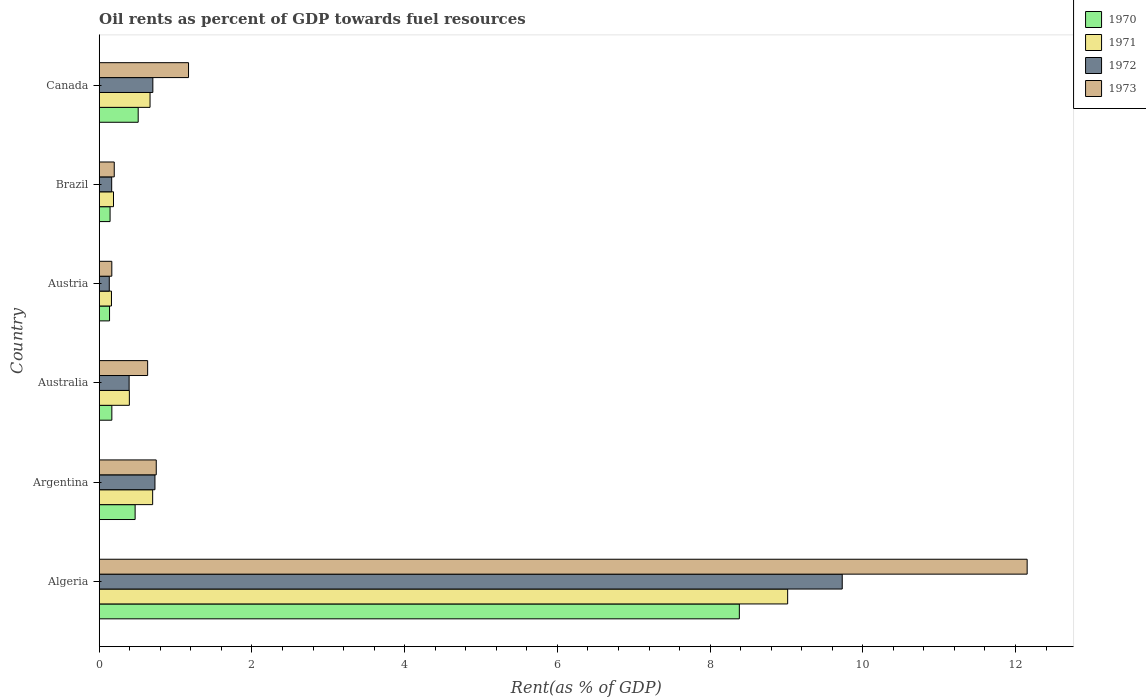How many different coloured bars are there?
Offer a terse response. 4. Are the number of bars per tick equal to the number of legend labels?
Offer a very short reply. Yes. Are the number of bars on each tick of the Y-axis equal?
Offer a very short reply. Yes. How many bars are there on the 4th tick from the bottom?
Offer a very short reply. 4. What is the label of the 6th group of bars from the top?
Keep it short and to the point. Algeria. In how many cases, is the number of bars for a given country not equal to the number of legend labels?
Provide a short and direct response. 0. What is the oil rent in 1970 in Canada?
Give a very brief answer. 0.51. Across all countries, what is the maximum oil rent in 1970?
Your answer should be very brief. 8.38. Across all countries, what is the minimum oil rent in 1970?
Provide a succinct answer. 0.14. In which country was the oil rent in 1970 maximum?
Your answer should be compact. Algeria. In which country was the oil rent in 1970 minimum?
Provide a short and direct response. Austria. What is the total oil rent in 1973 in the graph?
Offer a very short reply. 15.06. What is the difference between the oil rent in 1971 in Algeria and that in Brazil?
Your answer should be compact. 8.83. What is the difference between the oil rent in 1973 in Argentina and the oil rent in 1970 in Algeria?
Make the answer very short. -7.64. What is the average oil rent in 1972 per country?
Your answer should be compact. 1.97. What is the difference between the oil rent in 1970 and oil rent in 1972 in Canada?
Your answer should be very brief. -0.19. In how many countries, is the oil rent in 1971 greater than 3.6 %?
Keep it short and to the point. 1. What is the ratio of the oil rent in 1970 in Brazil to that in Canada?
Your response must be concise. 0.28. Is the oil rent in 1970 in Australia less than that in Brazil?
Keep it short and to the point. No. What is the difference between the highest and the second highest oil rent in 1973?
Keep it short and to the point. 10.98. What is the difference between the highest and the lowest oil rent in 1973?
Ensure brevity in your answer.  11.99. Is the sum of the oil rent in 1972 in Algeria and Canada greater than the maximum oil rent in 1973 across all countries?
Provide a succinct answer. No. Is it the case that in every country, the sum of the oil rent in 1971 and oil rent in 1972 is greater than the sum of oil rent in 1970 and oil rent in 1973?
Offer a very short reply. No. What does the 2nd bar from the bottom in Brazil represents?
Offer a terse response. 1971. Is it the case that in every country, the sum of the oil rent in 1972 and oil rent in 1971 is greater than the oil rent in 1973?
Offer a very short reply. Yes. How many bars are there?
Your answer should be very brief. 24. Are all the bars in the graph horizontal?
Keep it short and to the point. Yes. What is the difference between two consecutive major ticks on the X-axis?
Your response must be concise. 2. Are the values on the major ticks of X-axis written in scientific E-notation?
Give a very brief answer. No. Does the graph contain any zero values?
Keep it short and to the point. No. How many legend labels are there?
Ensure brevity in your answer.  4. How are the legend labels stacked?
Ensure brevity in your answer.  Vertical. What is the title of the graph?
Your response must be concise. Oil rents as percent of GDP towards fuel resources. What is the label or title of the X-axis?
Provide a short and direct response. Rent(as % of GDP). What is the Rent(as % of GDP) of 1970 in Algeria?
Ensure brevity in your answer.  8.38. What is the Rent(as % of GDP) of 1971 in Algeria?
Offer a terse response. 9.02. What is the Rent(as % of GDP) in 1972 in Algeria?
Your answer should be compact. 9.73. What is the Rent(as % of GDP) in 1973 in Algeria?
Your answer should be very brief. 12.15. What is the Rent(as % of GDP) of 1970 in Argentina?
Provide a short and direct response. 0.47. What is the Rent(as % of GDP) of 1971 in Argentina?
Your response must be concise. 0.7. What is the Rent(as % of GDP) in 1972 in Argentina?
Keep it short and to the point. 0.73. What is the Rent(as % of GDP) of 1973 in Argentina?
Your response must be concise. 0.75. What is the Rent(as % of GDP) of 1970 in Australia?
Your answer should be compact. 0.17. What is the Rent(as % of GDP) in 1971 in Australia?
Your answer should be very brief. 0.39. What is the Rent(as % of GDP) in 1972 in Australia?
Offer a terse response. 0.39. What is the Rent(as % of GDP) of 1973 in Australia?
Offer a very short reply. 0.63. What is the Rent(as % of GDP) of 1970 in Austria?
Ensure brevity in your answer.  0.14. What is the Rent(as % of GDP) in 1971 in Austria?
Ensure brevity in your answer.  0.16. What is the Rent(as % of GDP) in 1972 in Austria?
Your answer should be very brief. 0.13. What is the Rent(as % of GDP) of 1973 in Austria?
Your response must be concise. 0.16. What is the Rent(as % of GDP) of 1970 in Brazil?
Make the answer very short. 0.14. What is the Rent(as % of GDP) of 1971 in Brazil?
Your answer should be very brief. 0.19. What is the Rent(as % of GDP) of 1972 in Brazil?
Your answer should be very brief. 0.16. What is the Rent(as % of GDP) of 1973 in Brazil?
Make the answer very short. 0.2. What is the Rent(as % of GDP) of 1970 in Canada?
Provide a succinct answer. 0.51. What is the Rent(as % of GDP) of 1971 in Canada?
Make the answer very short. 0.67. What is the Rent(as % of GDP) of 1972 in Canada?
Ensure brevity in your answer.  0.7. What is the Rent(as % of GDP) in 1973 in Canada?
Keep it short and to the point. 1.17. Across all countries, what is the maximum Rent(as % of GDP) in 1970?
Offer a very short reply. 8.38. Across all countries, what is the maximum Rent(as % of GDP) of 1971?
Make the answer very short. 9.02. Across all countries, what is the maximum Rent(as % of GDP) of 1972?
Offer a very short reply. 9.73. Across all countries, what is the maximum Rent(as % of GDP) of 1973?
Your answer should be compact. 12.15. Across all countries, what is the minimum Rent(as % of GDP) of 1970?
Make the answer very short. 0.14. Across all countries, what is the minimum Rent(as % of GDP) in 1971?
Your answer should be compact. 0.16. Across all countries, what is the minimum Rent(as % of GDP) in 1972?
Offer a very short reply. 0.13. Across all countries, what is the minimum Rent(as % of GDP) in 1973?
Offer a terse response. 0.16. What is the total Rent(as % of GDP) of 1970 in the graph?
Your answer should be compact. 9.81. What is the total Rent(as % of GDP) of 1971 in the graph?
Offer a very short reply. 11.12. What is the total Rent(as % of GDP) of 1972 in the graph?
Provide a succinct answer. 11.85. What is the total Rent(as % of GDP) of 1973 in the graph?
Offer a very short reply. 15.06. What is the difference between the Rent(as % of GDP) in 1970 in Algeria and that in Argentina?
Give a very brief answer. 7.91. What is the difference between the Rent(as % of GDP) of 1971 in Algeria and that in Argentina?
Ensure brevity in your answer.  8.32. What is the difference between the Rent(as % of GDP) of 1972 in Algeria and that in Argentina?
Keep it short and to the point. 9. What is the difference between the Rent(as % of GDP) in 1973 in Algeria and that in Argentina?
Make the answer very short. 11.41. What is the difference between the Rent(as % of GDP) of 1970 in Algeria and that in Australia?
Provide a short and direct response. 8.22. What is the difference between the Rent(as % of GDP) of 1971 in Algeria and that in Australia?
Make the answer very short. 8.62. What is the difference between the Rent(as % of GDP) in 1972 in Algeria and that in Australia?
Offer a terse response. 9.34. What is the difference between the Rent(as % of GDP) in 1973 in Algeria and that in Australia?
Your answer should be very brief. 11.52. What is the difference between the Rent(as % of GDP) in 1970 in Algeria and that in Austria?
Ensure brevity in your answer.  8.25. What is the difference between the Rent(as % of GDP) of 1971 in Algeria and that in Austria?
Keep it short and to the point. 8.86. What is the difference between the Rent(as % of GDP) of 1972 in Algeria and that in Austria?
Make the answer very short. 9.6. What is the difference between the Rent(as % of GDP) in 1973 in Algeria and that in Austria?
Your answer should be very brief. 11.99. What is the difference between the Rent(as % of GDP) of 1970 in Algeria and that in Brazil?
Offer a very short reply. 8.24. What is the difference between the Rent(as % of GDP) of 1971 in Algeria and that in Brazil?
Offer a very short reply. 8.83. What is the difference between the Rent(as % of GDP) of 1972 in Algeria and that in Brazil?
Make the answer very short. 9.57. What is the difference between the Rent(as % of GDP) of 1973 in Algeria and that in Brazil?
Your answer should be compact. 11.96. What is the difference between the Rent(as % of GDP) of 1970 in Algeria and that in Canada?
Your answer should be compact. 7.87. What is the difference between the Rent(as % of GDP) in 1971 in Algeria and that in Canada?
Your answer should be compact. 8.35. What is the difference between the Rent(as % of GDP) in 1972 in Algeria and that in Canada?
Provide a short and direct response. 9.03. What is the difference between the Rent(as % of GDP) in 1973 in Algeria and that in Canada?
Ensure brevity in your answer.  10.98. What is the difference between the Rent(as % of GDP) in 1970 in Argentina and that in Australia?
Keep it short and to the point. 0.3. What is the difference between the Rent(as % of GDP) of 1971 in Argentina and that in Australia?
Give a very brief answer. 0.31. What is the difference between the Rent(as % of GDP) in 1972 in Argentina and that in Australia?
Your answer should be very brief. 0.34. What is the difference between the Rent(as % of GDP) of 1973 in Argentina and that in Australia?
Give a very brief answer. 0.11. What is the difference between the Rent(as % of GDP) of 1970 in Argentina and that in Austria?
Offer a terse response. 0.33. What is the difference between the Rent(as % of GDP) in 1971 in Argentina and that in Austria?
Make the answer very short. 0.54. What is the difference between the Rent(as % of GDP) in 1972 in Argentina and that in Austria?
Make the answer very short. 0.6. What is the difference between the Rent(as % of GDP) in 1973 in Argentina and that in Austria?
Provide a succinct answer. 0.58. What is the difference between the Rent(as % of GDP) of 1970 in Argentina and that in Brazil?
Ensure brevity in your answer.  0.33. What is the difference between the Rent(as % of GDP) in 1971 in Argentina and that in Brazil?
Your response must be concise. 0.51. What is the difference between the Rent(as % of GDP) of 1972 in Argentina and that in Brazil?
Offer a very short reply. 0.57. What is the difference between the Rent(as % of GDP) in 1973 in Argentina and that in Brazil?
Keep it short and to the point. 0.55. What is the difference between the Rent(as % of GDP) in 1970 in Argentina and that in Canada?
Provide a succinct answer. -0.04. What is the difference between the Rent(as % of GDP) in 1971 in Argentina and that in Canada?
Offer a terse response. 0.03. What is the difference between the Rent(as % of GDP) in 1972 in Argentina and that in Canada?
Keep it short and to the point. 0.03. What is the difference between the Rent(as % of GDP) in 1973 in Argentina and that in Canada?
Offer a very short reply. -0.42. What is the difference between the Rent(as % of GDP) of 1970 in Australia and that in Austria?
Your answer should be very brief. 0.03. What is the difference between the Rent(as % of GDP) of 1971 in Australia and that in Austria?
Make the answer very short. 0.23. What is the difference between the Rent(as % of GDP) in 1972 in Australia and that in Austria?
Offer a very short reply. 0.26. What is the difference between the Rent(as % of GDP) of 1973 in Australia and that in Austria?
Your answer should be very brief. 0.47. What is the difference between the Rent(as % of GDP) in 1970 in Australia and that in Brazil?
Your answer should be very brief. 0.02. What is the difference between the Rent(as % of GDP) in 1971 in Australia and that in Brazil?
Keep it short and to the point. 0.21. What is the difference between the Rent(as % of GDP) in 1972 in Australia and that in Brazil?
Provide a short and direct response. 0.23. What is the difference between the Rent(as % of GDP) in 1973 in Australia and that in Brazil?
Give a very brief answer. 0.44. What is the difference between the Rent(as % of GDP) in 1970 in Australia and that in Canada?
Provide a short and direct response. -0.35. What is the difference between the Rent(as % of GDP) of 1971 in Australia and that in Canada?
Your answer should be compact. -0.27. What is the difference between the Rent(as % of GDP) in 1972 in Australia and that in Canada?
Make the answer very short. -0.31. What is the difference between the Rent(as % of GDP) of 1973 in Australia and that in Canada?
Make the answer very short. -0.54. What is the difference between the Rent(as % of GDP) of 1970 in Austria and that in Brazil?
Your response must be concise. -0.01. What is the difference between the Rent(as % of GDP) of 1971 in Austria and that in Brazil?
Keep it short and to the point. -0.03. What is the difference between the Rent(as % of GDP) of 1972 in Austria and that in Brazil?
Provide a short and direct response. -0.03. What is the difference between the Rent(as % of GDP) in 1973 in Austria and that in Brazil?
Offer a terse response. -0.03. What is the difference between the Rent(as % of GDP) of 1970 in Austria and that in Canada?
Keep it short and to the point. -0.38. What is the difference between the Rent(as % of GDP) in 1971 in Austria and that in Canada?
Provide a succinct answer. -0.51. What is the difference between the Rent(as % of GDP) in 1972 in Austria and that in Canada?
Keep it short and to the point. -0.57. What is the difference between the Rent(as % of GDP) in 1973 in Austria and that in Canada?
Your answer should be very brief. -1. What is the difference between the Rent(as % of GDP) in 1970 in Brazil and that in Canada?
Give a very brief answer. -0.37. What is the difference between the Rent(as % of GDP) in 1971 in Brazil and that in Canada?
Ensure brevity in your answer.  -0.48. What is the difference between the Rent(as % of GDP) of 1972 in Brazil and that in Canada?
Offer a terse response. -0.54. What is the difference between the Rent(as % of GDP) in 1973 in Brazil and that in Canada?
Keep it short and to the point. -0.97. What is the difference between the Rent(as % of GDP) of 1970 in Algeria and the Rent(as % of GDP) of 1971 in Argentina?
Offer a terse response. 7.68. What is the difference between the Rent(as % of GDP) of 1970 in Algeria and the Rent(as % of GDP) of 1972 in Argentina?
Give a very brief answer. 7.65. What is the difference between the Rent(as % of GDP) in 1970 in Algeria and the Rent(as % of GDP) in 1973 in Argentina?
Your response must be concise. 7.64. What is the difference between the Rent(as % of GDP) in 1971 in Algeria and the Rent(as % of GDP) in 1972 in Argentina?
Offer a terse response. 8.29. What is the difference between the Rent(as % of GDP) in 1971 in Algeria and the Rent(as % of GDP) in 1973 in Argentina?
Provide a succinct answer. 8.27. What is the difference between the Rent(as % of GDP) in 1972 in Algeria and the Rent(as % of GDP) in 1973 in Argentina?
Make the answer very short. 8.98. What is the difference between the Rent(as % of GDP) in 1970 in Algeria and the Rent(as % of GDP) in 1971 in Australia?
Provide a short and direct response. 7.99. What is the difference between the Rent(as % of GDP) in 1970 in Algeria and the Rent(as % of GDP) in 1972 in Australia?
Offer a very short reply. 7.99. What is the difference between the Rent(as % of GDP) in 1970 in Algeria and the Rent(as % of GDP) in 1973 in Australia?
Your response must be concise. 7.75. What is the difference between the Rent(as % of GDP) of 1971 in Algeria and the Rent(as % of GDP) of 1972 in Australia?
Give a very brief answer. 8.62. What is the difference between the Rent(as % of GDP) of 1971 in Algeria and the Rent(as % of GDP) of 1973 in Australia?
Make the answer very short. 8.38. What is the difference between the Rent(as % of GDP) in 1972 in Algeria and the Rent(as % of GDP) in 1973 in Australia?
Provide a short and direct response. 9.1. What is the difference between the Rent(as % of GDP) of 1970 in Algeria and the Rent(as % of GDP) of 1971 in Austria?
Provide a short and direct response. 8.22. What is the difference between the Rent(as % of GDP) of 1970 in Algeria and the Rent(as % of GDP) of 1972 in Austria?
Offer a very short reply. 8.25. What is the difference between the Rent(as % of GDP) of 1970 in Algeria and the Rent(as % of GDP) of 1973 in Austria?
Provide a succinct answer. 8.22. What is the difference between the Rent(as % of GDP) of 1971 in Algeria and the Rent(as % of GDP) of 1972 in Austria?
Your answer should be very brief. 8.88. What is the difference between the Rent(as % of GDP) in 1971 in Algeria and the Rent(as % of GDP) in 1973 in Austria?
Provide a short and direct response. 8.85. What is the difference between the Rent(as % of GDP) in 1972 in Algeria and the Rent(as % of GDP) in 1973 in Austria?
Keep it short and to the point. 9.57. What is the difference between the Rent(as % of GDP) in 1970 in Algeria and the Rent(as % of GDP) in 1971 in Brazil?
Offer a very short reply. 8.2. What is the difference between the Rent(as % of GDP) of 1970 in Algeria and the Rent(as % of GDP) of 1972 in Brazil?
Give a very brief answer. 8.22. What is the difference between the Rent(as % of GDP) in 1970 in Algeria and the Rent(as % of GDP) in 1973 in Brazil?
Offer a terse response. 8.19. What is the difference between the Rent(as % of GDP) in 1971 in Algeria and the Rent(as % of GDP) in 1972 in Brazil?
Your response must be concise. 8.85. What is the difference between the Rent(as % of GDP) of 1971 in Algeria and the Rent(as % of GDP) of 1973 in Brazil?
Give a very brief answer. 8.82. What is the difference between the Rent(as % of GDP) in 1972 in Algeria and the Rent(as % of GDP) in 1973 in Brazil?
Make the answer very short. 9.53. What is the difference between the Rent(as % of GDP) of 1970 in Algeria and the Rent(as % of GDP) of 1971 in Canada?
Offer a terse response. 7.72. What is the difference between the Rent(as % of GDP) of 1970 in Algeria and the Rent(as % of GDP) of 1972 in Canada?
Ensure brevity in your answer.  7.68. What is the difference between the Rent(as % of GDP) in 1970 in Algeria and the Rent(as % of GDP) in 1973 in Canada?
Your answer should be compact. 7.21. What is the difference between the Rent(as % of GDP) in 1971 in Algeria and the Rent(as % of GDP) in 1972 in Canada?
Keep it short and to the point. 8.31. What is the difference between the Rent(as % of GDP) of 1971 in Algeria and the Rent(as % of GDP) of 1973 in Canada?
Keep it short and to the point. 7.85. What is the difference between the Rent(as % of GDP) in 1972 in Algeria and the Rent(as % of GDP) in 1973 in Canada?
Ensure brevity in your answer.  8.56. What is the difference between the Rent(as % of GDP) of 1970 in Argentina and the Rent(as % of GDP) of 1971 in Australia?
Provide a short and direct response. 0.08. What is the difference between the Rent(as % of GDP) in 1970 in Argentina and the Rent(as % of GDP) in 1972 in Australia?
Your answer should be compact. 0.08. What is the difference between the Rent(as % of GDP) in 1970 in Argentina and the Rent(as % of GDP) in 1973 in Australia?
Keep it short and to the point. -0.16. What is the difference between the Rent(as % of GDP) of 1971 in Argentina and the Rent(as % of GDP) of 1972 in Australia?
Provide a short and direct response. 0.31. What is the difference between the Rent(as % of GDP) of 1971 in Argentina and the Rent(as % of GDP) of 1973 in Australia?
Ensure brevity in your answer.  0.07. What is the difference between the Rent(as % of GDP) of 1972 in Argentina and the Rent(as % of GDP) of 1973 in Australia?
Keep it short and to the point. 0.1. What is the difference between the Rent(as % of GDP) in 1970 in Argentina and the Rent(as % of GDP) in 1971 in Austria?
Offer a very short reply. 0.31. What is the difference between the Rent(as % of GDP) of 1970 in Argentina and the Rent(as % of GDP) of 1972 in Austria?
Provide a short and direct response. 0.34. What is the difference between the Rent(as % of GDP) in 1970 in Argentina and the Rent(as % of GDP) in 1973 in Austria?
Offer a very short reply. 0.31. What is the difference between the Rent(as % of GDP) in 1971 in Argentina and the Rent(as % of GDP) in 1972 in Austria?
Make the answer very short. 0.57. What is the difference between the Rent(as % of GDP) of 1971 in Argentina and the Rent(as % of GDP) of 1973 in Austria?
Keep it short and to the point. 0.54. What is the difference between the Rent(as % of GDP) of 1972 in Argentina and the Rent(as % of GDP) of 1973 in Austria?
Ensure brevity in your answer.  0.57. What is the difference between the Rent(as % of GDP) of 1970 in Argentina and the Rent(as % of GDP) of 1971 in Brazil?
Offer a terse response. 0.28. What is the difference between the Rent(as % of GDP) of 1970 in Argentina and the Rent(as % of GDP) of 1972 in Brazil?
Provide a succinct answer. 0.31. What is the difference between the Rent(as % of GDP) of 1970 in Argentina and the Rent(as % of GDP) of 1973 in Brazil?
Offer a terse response. 0.27. What is the difference between the Rent(as % of GDP) of 1971 in Argentina and the Rent(as % of GDP) of 1972 in Brazil?
Make the answer very short. 0.54. What is the difference between the Rent(as % of GDP) in 1971 in Argentina and the Rent(as % of GDP) in 1973 in Brazil?
Keep it short and to the point. 0.5. What is the difference between the Rent(as % of GDP) in 1972 in Argentina and the Rent(as % of GDP) in 1973 in Brazil?
Provide a succinct answer. 0.53. What is the difference between the Rent(as % of GDP) in 1970 in Argentina and the Rent(as % of GDP) in 1971 in Canada?
Keep it short and to the point. -0.2. What is the difference between the Rent(as % of GDP) in 1970 in Argentina and the Rent(as % of GDP) in 1972 in Canada?
Make the answer very short. -0.23. What is the difference between the Rent(as % of GDP) in 1970 in Argentina and the Rent(as % of GDP) in 1973 in Canada?
Give a very brief answer. -0.7. What is the difference between the Rent(as % of GDP) in 1971 in Argentina and the Rent(as % of GDP) in 1972 in Canada?
Your response must be concise. -0. What is the difference between the Rent(as % of GDP) of 1971 in Argentina and the Rent(as % of GDP) of 1973 in Canada?
Offer a terse response. -0.47. What is the difference between the Rent(as % of GDP) in 1972 in Argentina and the Rent(as % of GDP) in 1973 in Canada?
Offer a very short reply. -0.44. What is the difference between the Rent(as % of GDP) in 1970 in Australia and the Rent(as % of GDP) in 1971 in Austria?
Provide a short and direct response. 0. What is the difference between the Rent(as % of GDP) of 1970 in Australia and the Rent(as % of GDP) of 1972 in Austria?
Make the answer very short. 0.03. What is the difference between the Rent(as % of GDP) of 1970 in Australia and the Rent(as % of GDP) of 1973 in Austria?
Offer a terse response. 0. What is the difference between the Rent(as % of GDP) of 1971 in Australia and the Rent(as % of GDP) of 1972 in Austria?
Keep it short and to the point. 0.26. What is the difference between the Rent(as % of GDP) in 1971 in Australia and the Rent(as % of GDP) in 1973 in Austria?
Keep it short and to the point. 0.23. What is the difference between the Rent(as % of GDP) in 1972 in Australia and the Rent(as % of GDP) in 1973 in Austria?
Give a very brief answer. 0.23. What is the difference between the Rent(as % of GDP) of 1970 in Australia and the Rent(as % of GDP) of 1971 in Brazil?
Provide a succinct answer. -0.02. What is the difference between the Rent(as % of GDP) of 1970 in Australia and the Rent(as % of GDP) of 1972 in Brazil?
Give a very brief answer. 0. What is the difference between the Rent(as % of GDP) in 1970 in Australia and the Rent(as % of GDP) in 1973 in Brazil?
Provide a succinct answer. -0.03. What is the difference between the Rent(as % of GDP) of 1971 in Australia and the Rent(as % of GDP) of 1972 in Brazil?
Your answer should be very brief. 0.23. What is the difference between the Rent(as % of GDP) in 1971 in Australia and the Rent(as % of GDP) in 1973 in Brazil?
Your response must be concise. 0.2. What is the difference between the Rent(as % of GDP) in 1972 in Australia and the Rent(as % of GDP) in 1973 in Brazil?
Provide a succinct answer. 0.19. What is the difference between the Rent(as % of GDP) in 1970 in Australia and the Rent(as % of GDP) in 1971 in Canada?
Provide a succinct answer. -0.5. What is the difference between the Rent(as % of GDP) in 1970 in Australia and the Rent(as % of GDP) in 1972 in Canada?
Give a very brief answer. -0.54. What is the difference between the Rent(as % of GDP) of 1970 in Australia and the Rent(as % of GDP) of 1973 in Canada?
Ensure brevity in your answer.  -1. What is the difference between the Rent(as % of GDP) of 1971 in Australia and the Rent(as % of GDP) of 1972 in Canada?
Keep it short and to the point. -0.31. What is the difference between the Rent(as % of GDP) in 1971 in Australia and the Rent(as % of GDP) in 1973 in Canada?
Make the answer very short. -0.77. What is the difference between the Rent(as % of GDP) in 1972 in Australia and the Rent(as % of GDP) in 1973 in Canada?
Your answer should be very brief. -0.78. What is the difference between the Rent(as % of GDP) in 1970 in Austria and the Rent(as % of GDP) in 1971 in Brazil?
Give a very brief answer. -0.05. What is the difference between the Rent(as % of GDP) of 1970 in Austria and the Rent(as % of GDP) of 1972 in Brazil?
Provide a succinct answer. -0.03. What is the difference between the Rent(as % of GDP) in 1970 in Austria and the Rent(as % of GDP) in 1973 in Brazil?
Provide a short and direct response. -0.06. What is the difference between the Rent(as % of GDP) in 1971 in Austria and the Rent(as % of GDP) in 1972 in Brazil?
Offer a very short reply. -0. What is the difference between the Rent(as % of GDP) in 1971 in Austria and the Rent(as % of GDP) in 1973 in Brazil?
Ensure brevity in your answer.  -0.04. What is the difference between the Rent(as % of GDP) of 1972 in Austria and the Rent(as % of GDP) of 1973 in Brazil?
Your answer should be compact. -0.07. What is the difference between the Rent(as % of GDP) in 1970 in Austria and the Rent(as % of GDP) in 1971 in Canada?
Provide a short and direct response. -0.53. What is the difference between the Rent(as % of GDP) in 1970 in Austria and the Rent(as % of GDP) in 1972 in Canada?
Your answer should be compact. -0.57. What is the difference between the Rent(as % of GDP) in 1970 in Austria and the Rent(as % of GDP) in 1973 in Canada?
Your answer should be very brief. -1.03. What is the difference between the Rent(as % of GDP) in 1971 in Austria and the Rent(as % of GDP) in 1972 in Canada?
Offer a very short reply. -0.54. What is the difference between the Rent(as % of GDP) of 1971 in Austria and the Rent(as % of GDP) of 1973 in Canada?
Ensure brevity in your answer.  -1.01. What is the difference between the Rent(as % of GDP) of 1972 in Austria and the Rent(as % of GDP) of 1973 in Canada?
Keep it short and to the point. -1.04. What is the difference between the Rent(as % of GDP) of 1970 in Brazil and the Rent(as % of GDP) of 1971 in Canada?
Give a very brief answer. -0.52. What is the difference between the Rent(as % of GDP) of 1970 in Brazil and the Rent(as % of GDP) of 1972 in Canada?
Your answer should be compact. -0.56. What is the difference between the Rent(as % of GDP) in 1970 in Brazil and the Rent(as % of GDP) in 1973 in Canada?
Your answer should be compact. -1.03. What is the difference between the Rent(as % of GDP) of 1971 in Brazil and the Rent(as % of GDP) of 1972 in Canada?
Make the answer very short. -0.52. What is the difference between the Rent(as % of GDP) in 1971 in Brazil and the Rent(as % of GDP) in 1973 in Canada?
Ensure brevity in your answer.  -0.98. What is the difference between the Rent(as % of GDP) in 1972 in Brazil and the Rent(as % of GDP) in 1973 in Canada?
Your answer should be very brief. -1.01. What is the average Rent(as % of GDP) in 1970 per country?
Ensure brevity in your answer.  1.63. What is the average Rent(as % of GDP) in 1971 per country?
Your response must be concise. 1.85. What is the average Rent(as % of GDP) in 1972 per country?
Provide a short and direct response. 1.97. What is the average Rent(as % of GDP) of 1973 per country?
Your response must be concise. 2.51. What is the difference between the Rent(as % of GDP) of 1970 and Rent(as % of GDP) of 1971 in Algeria?
Provide a succinct answer. -0.63. What is the difference between the Rent(as % of GDP) of 1970 and Rent(as % of GDP) of 1972 in Algeria?
Give a very brief answer. -1.35. What is the difference between the Rent(as % of GDP) in 1970 and Rent(as % of GDP) in 1973 in Algeria?
Give a very brief answer. -3.77. What is the difference between the Rent(as % of GDP) of 1971 and Rent(as % of GDP) of 1972 in Algeria?
Ensure brevity in your answer.  -0.71. What is the difference between the Rent(as % of GDP) of 1971 and Rent(as % of GDP) of 1973 in Algeria?
Your answer should be very brief. -3.14. What is the difference between the Rent(as % of GDP) in 1972 and Rent(as % of GDP) in 1973 in Algeria?
Your answer should be very brief. -2.42. What is the difference between the Rent(as % of GDP) in 1970 and Rent(as % of GDP) in 1971 in Argentina?
Your answer should be very brief. -0.23. What is the difference between the Rent(as % of GDP) in 1970 and Rent(as % of GDP) in 1972 in Argentina?
Make the answer very short. -0.26. What is the difference between the Rent(as % of GDP) of 1970 and Rent(as % of GDP) of 1973 in Argentina?
Make the answer very short. -0.28. What is the difference between the Rent(as % of GDP) of 1971 and Rent(as % of GDP) of 1972 in Argentina?
Offer a very short reply. -0.03. What is the difference between the Rent(as % of GDP) in 1971 and Rent(as % of GDP) in 1973 in Argentina?
Provide a succinct answer. -0.05. What is the difference between the Rent(as % of GDP) in 1972 and Rent(as % of GDP) in 1973 in Argentina?
Your answer should be very brief. -0.02. What is the difference between the Rent(as % of GDP) of 1970 and Rent(as % of GDP) of 1971 in Australia?
Keep it short and to the point. -0.23. What is the difference between the Rent(as % of GDP) of 1970 and Rent(as % of GDP) of 1972 in Australia?
Make the answer very short. -0.23. What is the difference between the Rent(as % of GDP) in 1970 and Rent(as % of GDP) in 1973 in Australia?
Offer a terse response. -0.47. What is the difference between the Rent(as % of GDP) of 1971 and Rent(as % of GDP) of 1972 in Australia?
Give a very brief answer. 0. What is the difference between the Rent(as % of GDP) in 1971 and Rent(as % of GDP) in 1973 in Australia?
Your answer should be very brief. -0.24. What is the difference between the Rent(as % of GDP) in 1972 and Rent(as % of GDP) in 1973 in Australia?
Keep it short and to the point. -0.24. What is the difference between the Rent(as % of GDP) in 1970 and Rent(as % of GDP) in 1971 in Austria?
Give a very brief answer. -0.03. What is the difference between the Rent(as % of GDP) in 1970 and Rent(as % of GDP) in 1972 in Austria?
Offer a very short reply. 0. What is the difference between the Rent(as % of GDP) of 1970 and Rent(as % of GDP) of 1973 in Austria?
Keep it short and to the point. -0.03. What is the difference between the Rent(as % of GDP) in 1971 and Rent(as % of GDP) in 1972 in Austria?
Your response must be concise. 0.03. What is the difference between the Rent(as % of GDP) in 1971 and Rent(as % of GDP) in 1973 in Austria?
Offer a very short reply. -0. What is the difference between the Rent(as % of GDP) of 1972 and Rent(as % of GDP) of 1973 in Austria?
Make the answer very short. -0.03. What is the difference between the Rent(as % of GDP) in 1970 and Rent(as % of GDP) in 1971 in Brazil?
Offer a very short reply. -0.04. What is the difference between the Rent(as % of GDP) of 1970 and Rent(as % of GDP) of 1972 in Brazil?
Your answer should be compact. -0.02. What is the difference between the Rent(as % of GDP) in 1970 and Rent(as % of GDP) in 1973 in Brazil?
Give a very brief answer. -0.05. What is the difference between the Rent(as % of GDP) of 1971 and Rent(as % of GDP) of 1972 in Brazil?
Keep it short and to the point. 0.02. What is the difference between the Rent(as % of GDP) in 1971 and Rent(as % of GDP) in 1973 in Brazil?
Give a very brief answer. -0.01. What is the difference between the Rent(as % of GDP) of 1972 and Rent(as % of GDP) of 1973 in Brazil?
Your answer should be very brief. -0.03. What is the difference between the Rent(as % of GDP) in 1970 and Rent(as % of GDP) in 1971 in Canada?
Provide a succinct answer. -0.16. What is the difference between the Rent(as % of GDP) in 1970 and Rent(as % of GDP) in 1972 in Canada?
Your response must be concise. -0.19. What is the difference between the Rent(as % of GDP) of 1970 and Rent(as % of GDP) of 1973 in Canada?
Your answer should be compact. -0.66. What is the difference between the Rent(as % of GDP) of 1971 and Rent(as % of GDP) of 1972 in Canada?
Provide a succinct answer. -0.04. What is the difference between the Rent(as % of GDP) in 1971 and Rent(as % of GDP) in 1973 in Canada?
Provide a succinct answer. -0.5. What is the difference between the Rent(as % of GDP) of 1972 and Rent(as % of GDP) of 1973 in Canada?
Keep it short and to the point. -0.47. What is the ratio of the Rent(as % of GDP) in 1970 in Algeria to that in Argentina?
Ensure brevity in your answer.  17.83. What is the ratio of the Rent(as % of GDP) in 1971 in Algeria to that in Argentina?
Offer a terse response. 12.88. What is the ratio of the Rent(as % of GDP) in 1972 in Algeria to that in Argentina?
Ensure brevity in your answer.  13.33. What is the ratio of the Rent(as % of GDP) of 1973 in Algeria to that in Argentina?
Your answer should be compact. 16.27. What is the ratio of the Rent(as % of GDP) of 1970 in Algeria to that in Australia?
Offer a terse response. 50.73. What is the ratio of the Rent(as % of GDP) in 1971 in Algeria to that in Australia?
Your answer should be very brief. 22.84. What is the ratio of the Rent(as % of GDP) of 1972 in Algeria to that in Australia?
Your response must be concise. 24.84. What is the ratio of the Rent(as % of GDP) of 1973 in Algeria to that in Australia?
Give a very brief answer. 19.16. What is the ratio of the Rent(as % of GDP) in 1970 in Algeria to that in Austria?
Make the answer very short. 61.94. What is the ratio of the Rent(as % of GDP) of 1971 in Algeria to that in Austria?
Your answer should be very brief. 56.22. What is the ratio of the Rent(as % of GDP) of 1972 in Algeria to that in Austria?
Keep it short and to the point. 73.89. What is the ratio of the Rent(as % of GDP) in 1973 in Algeria to that in Austria?
Ensure brevity in your answer.  73.69. What is the ratio of the Rent(as % of GDP) of 1970 in Algeria to that in Brazil?
Offer a very short reply. 58.95. What is the ratio of the Rent(as % of GDP) of 1971 in Algeria to that in Brazil?
Ensure brevity in your answer.  48.18. What is the ratio of the Rent(as % of GDP) of 1972 in Algeria to that in Brazil?
Your response must be concise. 59.58. What is the ratio of the Rent(as % of GDP) in 1973 in Algeria to that in Brazil?
Provide a succinct answer. 61.73. What is the ratio of the Rent(as % of GDP) of 1970 in Algeria to that in Canada?
Keep it short and to the point. 16.42. What is the ratio of the Rent(as % of GDP) of 1971 in Algeria to that in Canada?
Your response must be concise. 13.54. What is the ratio of the Rent(as % of GDP) in 1972 in Algeria to that in Canada?
Offer a terse response. 13.85. What is the ratio of the Rent(as % of GDP) in 1973 in Algeria to that in Canada?
Make the answer very short. 10.39. What is the ratio of the Rent(as % of GDP) in 1970 in Argentina to that in Australia?
Offer a terse response. 2.85. What is the ratio of the Rent(as % of GDP) in 1971 in Argentina to that in Australia?
Your answer should be very brief. 1.77. What is the ratio of the Rent(as % of GDP) of 1972 in Argentina to that in Australia?
Your response must be concise. 1.86. What is the ratio of the Rent(as % of GDP) in 1973 in Argentina to that in Australia?
Ensure brevity in your answer.  1.18. What is the ratio of the Rent(as % of GDP) in 1970 in Argentina to that in Austria?
Ensure brevity in your answer.  3.47. What is the ratio of the Rent(as % of GDP) of 1971 in Argentina to that in Austria?
Give a very brief answer. 4.36. What is the ratio of the Rent(as % of GDP) in 1972 in Argentina to that in Austria?
Your answer should be compact. 5.54. What is the ratio of the Rent(as % of GDP) in 1973 in Argentina to that in Austria?
Your answer should be very brief. 4.53. What is the ratio of the Rent(as % of GDP) of 1970 in Argentina to that in Brazil?
Keep it short and to the point. 3.31. What is the ratio of the Rent(as % of GDP) in 1971 in Argentina to that in Brazil?
Your answer should be compact. 3.74. What is the ratio of the Rent(as % of GDP) in 1972 in Argentina to that in Brazil?
Your answer should be compact. 4.47. What is the ratio of the Rent(as % of GDP) in 1973 in Argentina to that in Brazil?
Ensure brevity in your answer.  3.79. What is the ratio of the Rent(as % of GDP) of 1970 in Argentina to that in Canada?
Your response must be concise. 0.92. What is the ratio of the Rent(as % of GDP) of 1971 in Argentina to that in Canada?
Keep it short and to the point. 1.05. What is the ratio of the Rent(as % of GDP) of 1972 in Argentina to that in Canada?
Your answer should be very brief. 1.04. What is the ratio of the Rent(as % of GDP) of 1973 in Argentina to that in Canada?
Offer a very short reply. 0.64. What is the ratio of the Rent(as % of GDP) of 1970 in Australia to that in Austria?
Your answer should be compact. 1.22. What is the ratio of the Rent(as % of GDP) of 1971 in Australia to that in Austria?
Your answer should be compact. 2.46. What is the ratio of the Rent(as % of GDP) in 1972 in Australia to that in Austria?
Offer a very short reply. 2.97. What is the ratio of the Rent(as % of GDP) in 1973 in Australia to that in Austria?
Keep it short and to the point. 3.85. What is the ratio of the Rent(as % of GDP) of 1970 in Australia to that in Brazil?
Provide a succinct answer. 1.16. What is the ratio of the Rent(as % of GDP) of 1971 in Australia to that in Brazil?
Make the answer very short. 2.11. What is the ratio of the Rent(as % of GDP) of 1972 in Australia to that in Brazil?
Your response must be concise. 2.4. What is the ratio of the Rent(as % of GDP) in 1973 in Australia to that in Brazil?
Keep it short and to the point. 3.22. What is the ratio of the Rent(as % of GDP) of 1970 in Australia to that in Canada?
Offer a very short reply. 0.32. What is the ratio of the Rent(as % of GDP) of 1971 in Australia to that in Canada?
Give a very brief answer. 0.59. What is the ratio of the Rent(as % of GDP) of 1972 in Australia to that in Canada?
Provide a short and direct response. 0.56. What is the ratio of the Rent(as % of GDP) in 1973 in Australia to that in Canada?
Make the answer very short. 0.54. What is the ratio of the Rent(as % of GDP) of 1970 in Austria to that in Brazil?
Keep it short and to the point. 0.95. What is the ratio of the Rent(as % of GDP) of 1971 in Austria to that in Brazil?
Provide a short and direct response. 0.86. What is the ratio of the Rent(as % of GDP) of 1972 in Austria to that in Brazil?
Keep it short and to the point. 0.81. What is the ratio of the Rent(as % of GDP) of 1973 in Austria to that in Brazil?
Your answer should be compact. 0.84. What is the ratio of the Rent(as % of GDP) of 1970 in Austria to that in Canada?
Your answer should be compact. 0.27. What is the ratio of the Rent(as % of GDP) in 1971 in Austria to that in Canada?
Your answer should be compact. 0.24. What is the ratio of the Rent(as % of GDP) of 1972 in Austria to that in Canada?
Offer a very short reply. 0.19. What is the ratio of the Rent(as % of GDP) of 1973 in Austria to that in Canada?
Your answer should be compact. 0.14. What is the ratio of the Rent(as % of GDP) of 1970 in Brazil to that in Canada?
Your answer should be compact. 0.28. What is the ratio of the Rent(as % of GDP) in 1971 in Brazil to that in Canada?
Your response must be concise. 0.28. What is the ratio of the Rent(as % of GDP) in 1972 in Brazil to that in Canada?
Make the answer very short. 0.23. What is the ratio of the Rent(as % of GDP) of 1973 in Brazil to that in Canada?
Make the answer very short. 0.17. What is the difference between the highest and the second highest Rent(as % of GDP) of 1970?
Provide a short and direct response. 7.87. What is the difference between the highest and the second highest Rent(as % of GDP) in 1971?
Provide a succinct answer. 8.32. What is the difference between the highest and the second highest Rent(as % of GDP) of 1972?
Your response must be concise. 9. What is the difference between the highest and the second highest Rent(as % of GDP) of 1973?
Keep it short and to the point. 10.98. What is the difference between the highest and the lowest Rent(as % of GDP) of 1970?
Provide a succinct answer. 8.25. What is the difference between the highest and the lowest Rent(as % of GDP) in 1971?
Make the answer very short. 8.86. What is the difference between the highest and the lowest Rent(as % of GDP) in 1972?
Provide a succinct answer. 9.6. What is the difference between the highest and the lowest Rent(as % of GDP) of 1973?
Offer a very short reply. 11.99. 